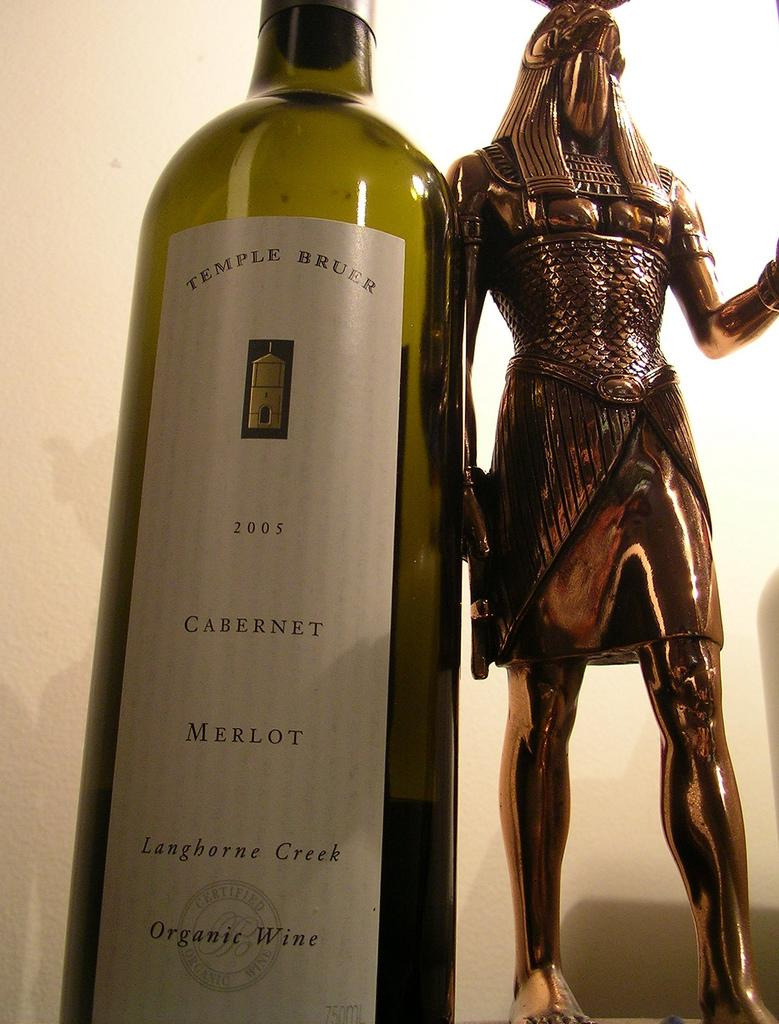<image>
Present a compact description of the photo's key features. A bottle of Temple Bruer next to a bronze statue. 